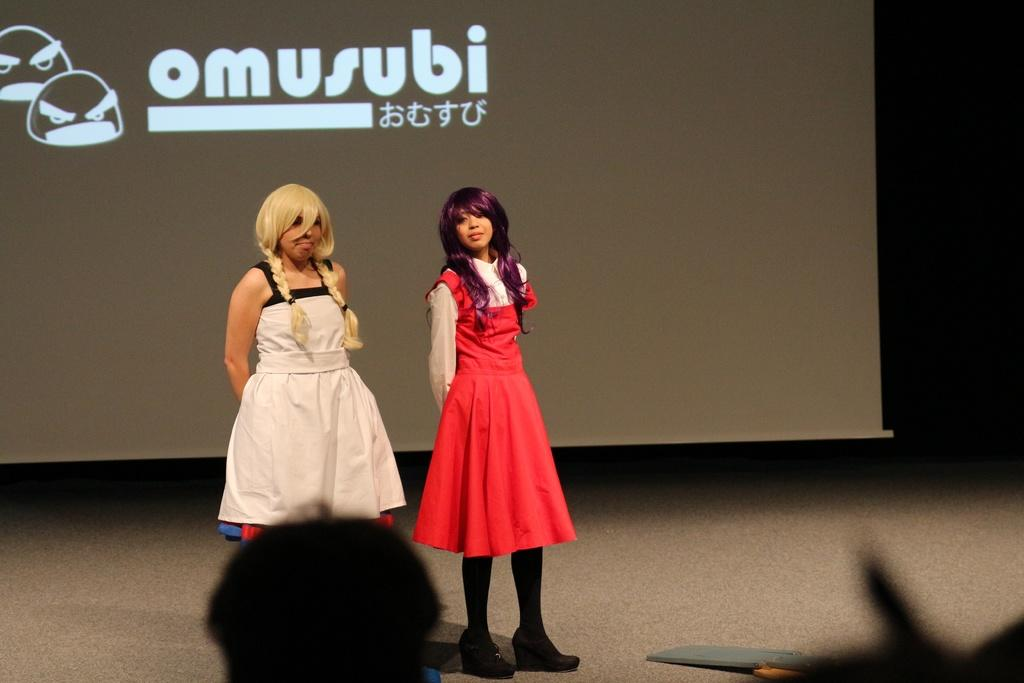How many people are in the image? There are two women in the image. What are the women doing in the image? The women are standing on the floor. What can be seen in the background of the image? There is a projector display screen in the background of the image. What type of silver is being used by the women in the image? There is no silver present in the image; the women are simply standing on the floor. What is the income level of the women in the image? There is no information about the income level of the women in the image. 